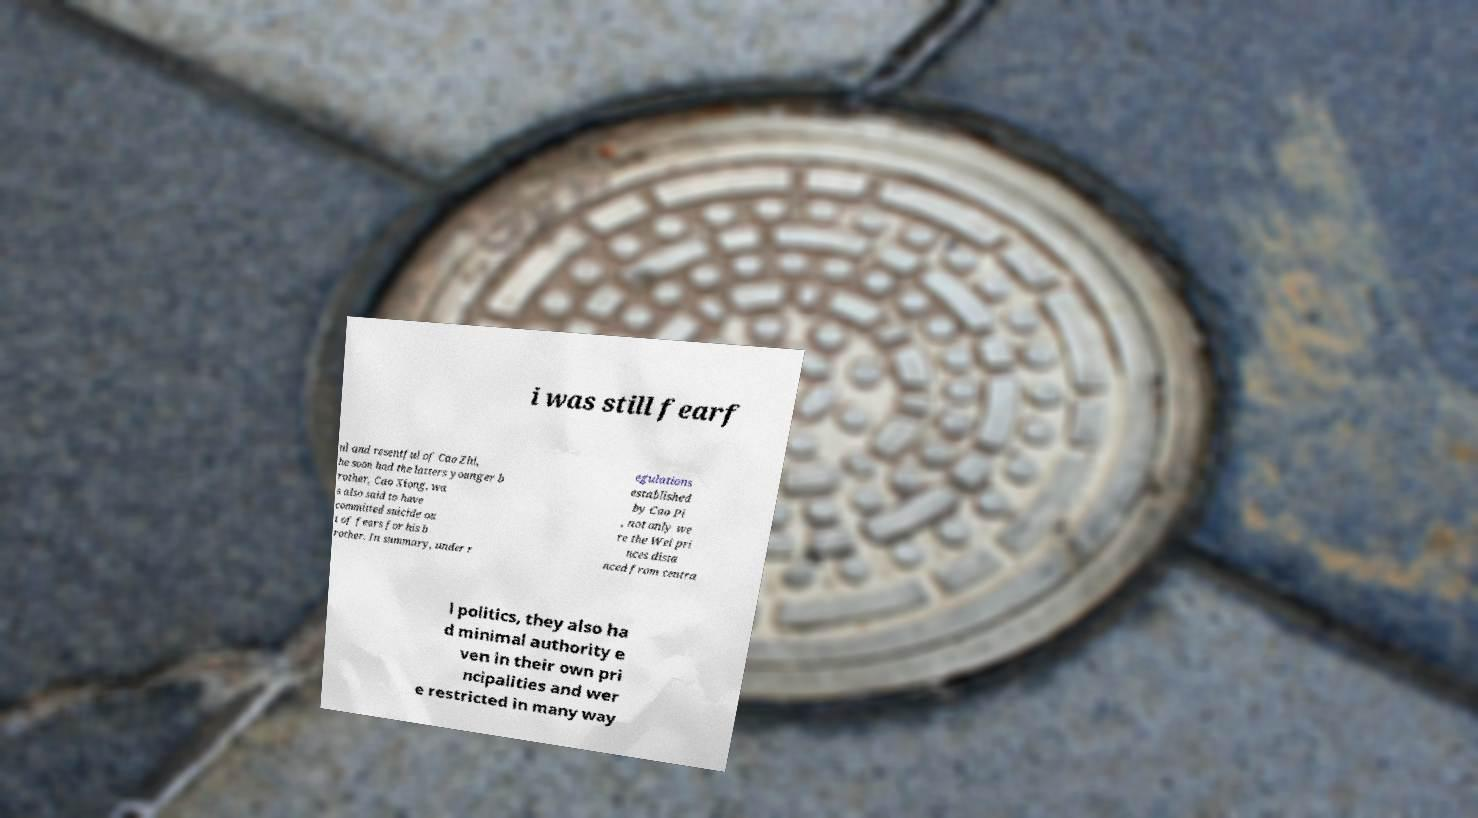There's text embedded in this image that I need extracted. Can you transcribe it verbatim? i was still fearf ul and resentful of Cao Zhi, he soon had the latters younger b rother, Cao Xiong, wa s also said to have committed suicide ou t of fears for his b rother. In summary, under r egulations established by Cao Pi , not only we re the Wei pri nces dista nced from centra l politics, they also ha d minimal authority e ven in their own pri ncipalities and wer e restricted in many way 